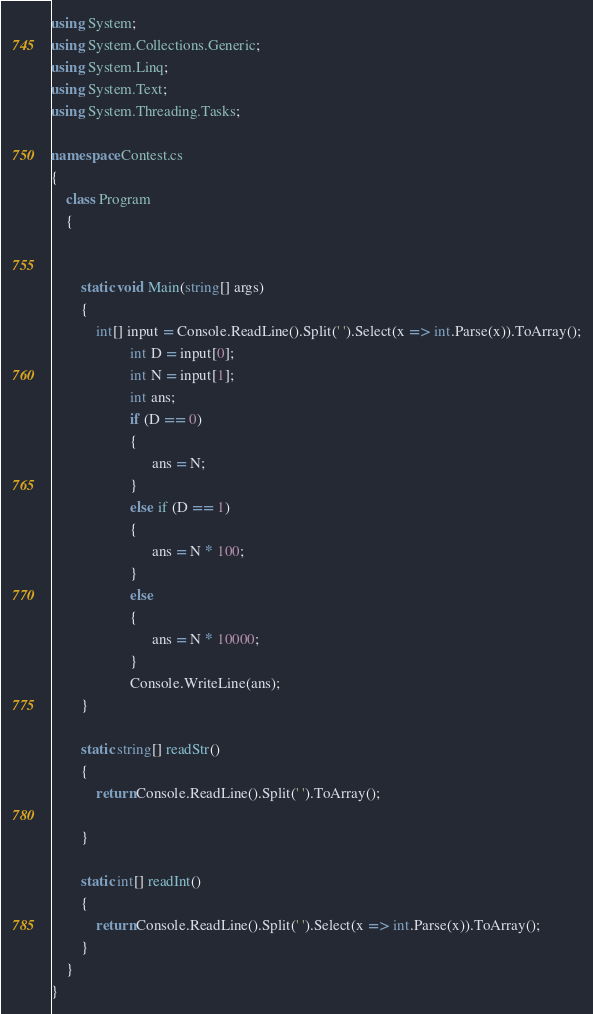Convert code to text. <code><loc_0><loc_0><loc_500><loc_500><_C#_>using System;
using System.Collections.Generic;
using System.Linq;
using System.Text;
using System.Threading.Tasks;

namespace Contest.cs
{
	class Program
	{


		static void Main(string[] args)
		{
			int[] input = Console.ReadLine().Split(' ').Select(x => int.Parse(x)).ToArray();
                     int D = input[0];
                     int N = input[1];
                     int ans;
                     if (D == 0)
                     {
                           ans = N;
                     }
                     else if (D == 1)
                     {
                           ans = N * 100;
                     }
                     else
                     {
                           ans = N * 10000;
                     }
                     Console.WriteLine(ans);
		}

		static string[] readStr()
		{
			return Console.ReadLine().Split(' ').ToArray();

		}

		static int[] readInt()
		{
			return Console.ReadLine().Split(' ').Select(x => int.Parse(x)).ToArray();
		}
	}
}
</code> 